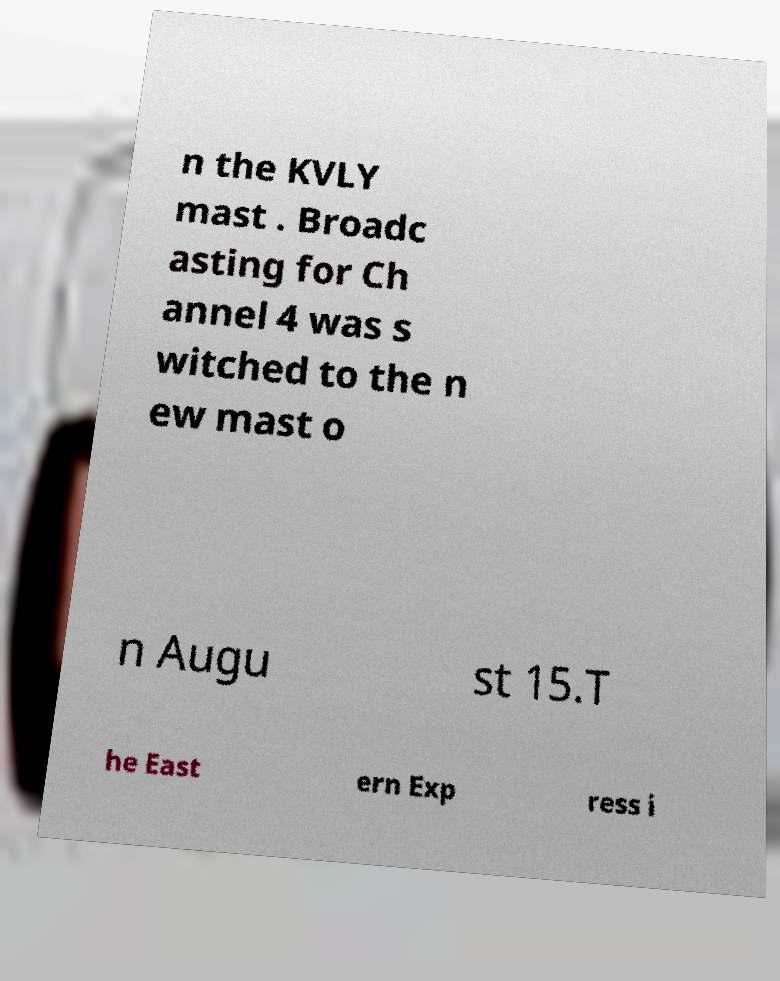Can you read and provide the text displayed in the image?This photo seems to have some interesting text. Can you extract and type it out for me? n the KVLY mast . Broadc asting for Ch annel 4 was s witched to the n ew mast o n Augu st 15.T he East ern Exp ress i 